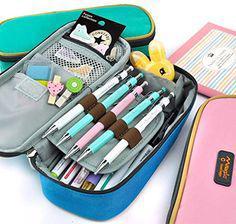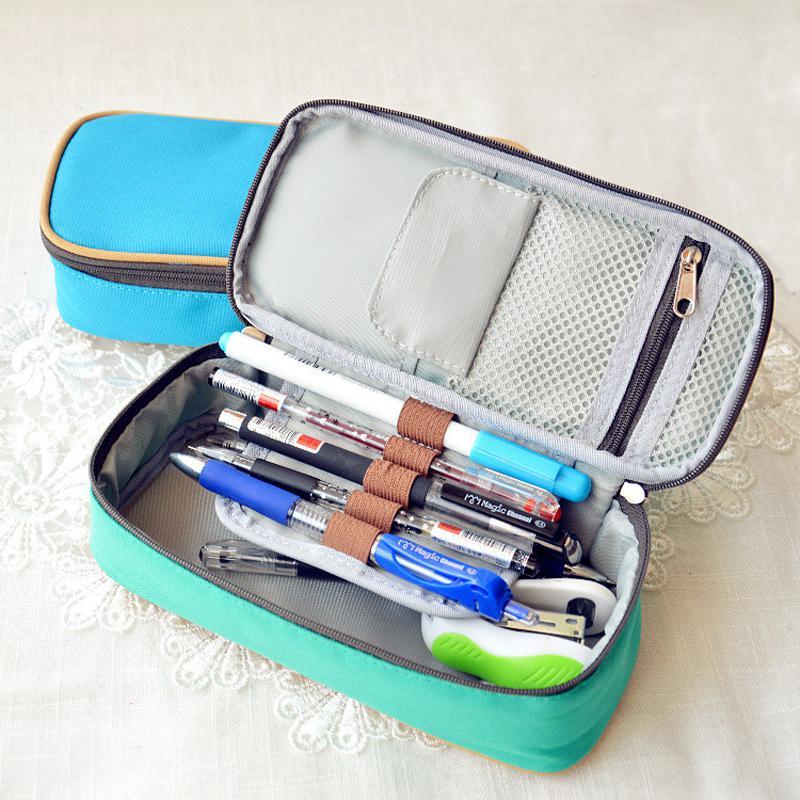The first image is the image on the left, the second image is the image on the right. Given the left and right images, does the statement "Left image shows an open blue case filled with writing supplies." hold true? Answer yes or no. Yes. The first image is the image on the left, the second image is the image on the right. Given the left and right images, does the statement "The bags in one of the images are decorated with words." hold true? Answer yes or no. No. 